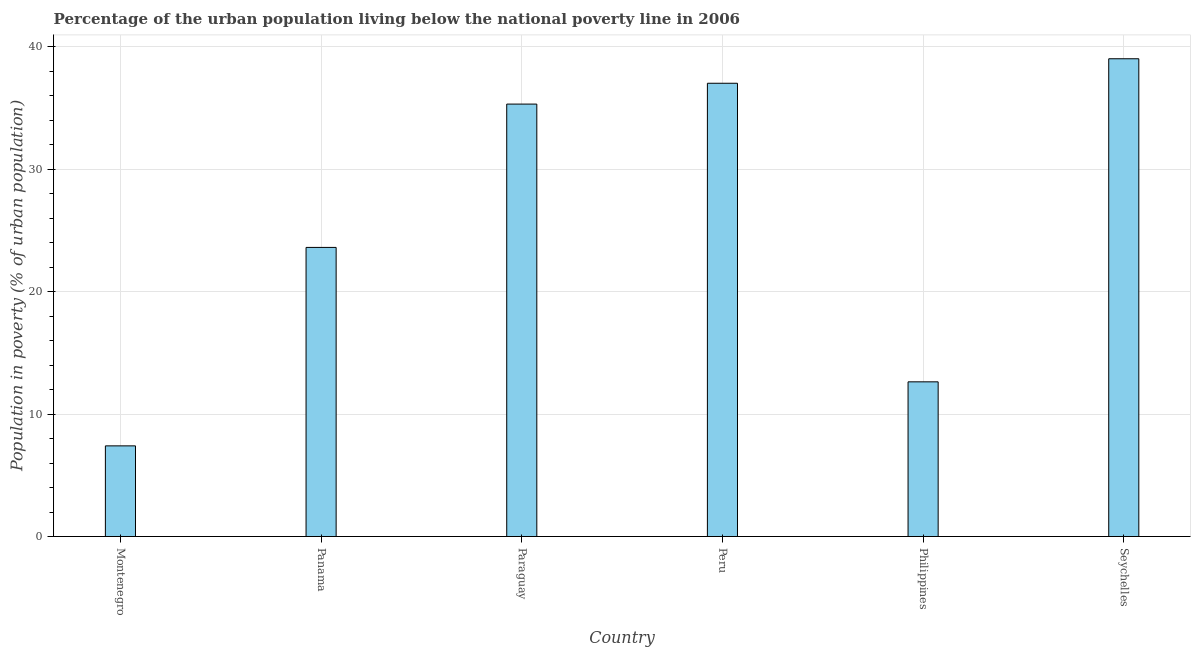Does the graph contain any zero values?
Offer a very short reply. No. Does the graph contain grids?
Give a very brief answer. Yes. What is the title of the graph?
Your response must be concise. Percentage of the urban population living below the national poverty line in 2006. What is the label or title of the Y-axis?
Provide a short and direct response. Population in poverty (% of urban population). What is the percentage of urban population living below poverty line in Montenegro?
Provide a succinct answer. 7.4. Across all countries, what is the maximum percentage of urban population living below poverty line?
Offer a very short reply. 39. Across all countries, what is the minimum percentage of urban population living below poverty line?
Your response must be concise. 7.4. In which country was the percentage of urban population living below poverty line maximum?
Ensure brevity in your answer.  Seychelles. In which country was the percentage of urban population living below poverty line minimum?
Keep it short and to the point. Montenegro. What is the sum of the percentage of urban population living below poverty line?
Give a very brief answer. 154.93. What is the difference between the percentage of urban population living below poverty line in Peru and Philippines?
Provide a short and direct response. 24.37. What is the average percentage of urban population living below poverty line per country?
Your answer should be compact. 25.82. What is the median percentage of urban population living below poverty line?
Provide a succinct answer. 29.45. In how many countries, is the percentage of urban population living below poverty line greater than 20 %?
Keep it short and to the point. 4. What is the ratio of the percentage of urban population living below poverty line in Paraguay to that in Peru?
Provide a succinct answer. 0.95. Is the percentage of urban population living below poverty line in Peru less than that in Philippines?
Make the answer very short. No. Is the sum of the percentage of urban population living below poverty line in Paraguay and Seychelles greater than the maximum percentage of urban population living below poverty line across all countries?
Give a very brief answer. Yes. What is the difference between the highest and the lowest percentage of urban population living below poverty line?
Offer a terse response. 31.6. In how many countries, is the percentage of urban population living below poverty line greater than the average percentage of urban population living below poverty line taken over all countries?
Provide a succinct answer. 3. How many bars are there?
Keep it short and to the point. 6. What is the difference between two consecutive major ticks on the Y-axis?
Give a very brief answer. 10. What is the Population in poverty (% of urban population) in Montenegro?
Provide a short and direct response. 7.4. What is the Population in poverty (% of urban population) of Panama?
Your answer should be compact. 23.6. What is the Population in poverty (% of urban population) of Paraguay?
Make the answer very short. 35.3. What is the Population in poverty (% of urban population) of Philippines?
Offer a terse response. 12.63. What is the Population in poverty (% of urban population) in Seychelles?
Your answer should be very brief. 39. What is the difference between the Population in poverty (% of urban population) in Montenegro and Panama?
Provide a short and direct response. -16.2. What is the difference between the Population in poverty (% of urban population) in Montenegro and Paraguay?
Offer a terse response. -27.9. What is the difference between the Population in poverty (% of urban population) in Montenegro and Peru?
Your answer should be very brief. -29.6. What is the difference between the Population in poverty (% of urban population) in Montenegro and Philippines?
Offer a very short reply. -5.23. What is the difference between the Population in poverty (% of urban population) in Montenegro and Seychelles?
Make the answer very short. -31.6. What is the difference between the Population in poverty (% of urban population) in Panama and Paraguay?
Make the answer very short. -11.7. What is the difference between the Population in poverty (% of urban population) in Panama and Philippines?
Give a very brief answer. 10.97. What is the difference between the Population in poverty (% of urban population) in Panama and Seychelles?
Provide a short and direct response. -15.4. What is the difference between the Population in poverty (% of urban population) in Paraguay and Philippines?
Your answer should be very brief. 22.67. What is the difference between the Population in poverty (% of urban population) in Paraguay and Seychelles?
Your answer should be very brief. -3.7. What is the difference between the Population in poverty (% of urban population) in Peru and Philippines?
Offer a very short reply. 24.37. What is the difference between the Population in poverty (% of urban population) in Peru and Seychelles?
Offer a very short reply. -2. What is the difference between the Population in poverty (% of urban population) in Philippines and Seychelles?
Offer a very short reply. -26.37. What is the ratio of the Population in poverty (% of urban population) in Montenegro to that in Panama?
Offer a terse response. 0.31. What is the ratio of the Population in poverty (% of urban population) in Montenegro to that in Paraguay?
Ensure brevity in your answer.  0.21. What is the ratio of the Population in poverty (% of urban population) in Montenegro to that in Peru?
Offer a terse response. 0.2. What is the ratio of the Population in poverty (% of urban population) in Montenegro to that in Philippines?
Ensure brevity in your answer.  0.59. What is the ratio of the Population in poverty (% of urban population) in Montenegro to that in Seychelles?
Keep it short and to the point. 0.19. What is the ratio of the Population in poverty (% of urban population) in Panama to that in Paraguay?
Your answer should be very brief. 0.67. What is the ratio of the Population in poverty (% of urban population) in Panama to that in Peru?
Ensure brevity in your answer.  0.64. What is the ratio of the Population in poverty (% of urban population) in Panama to that in Philippines?
Your response must be concise. 1.87. What is the ratio of the Population in poverty (% of urban population) in Panama to that in Seychelles?
Offer a very short reply. 0.6. What is the ratio of the Population in poverty (% of urban population) in Paraguay to that in Peru?
Make the answer very short. 0.95. What is the ratio of the Population in poverty (% of urban population) in Paraguay to that in Philippines?
Make the answer very short. 2.8. What is the ratio of the Population in poverty (% of urban population) in Paraguay to that in Seychelles?
Ensure brevity in your answer.  0.91. What is the ratio of the Population in poverty (% of urban population) in Peru to that in Philippines?
Provide a succinct answer. 2.93. What is the ratio of the Population in poverty (% of urban population) in Peru to that in Seychelles?
Provide a short and direct response. 0.95. What is the ratio of the Population in poverty (% of urban population) in Philippines to that in Seychelles?
Ensure brevity in your answer.  0.32. 